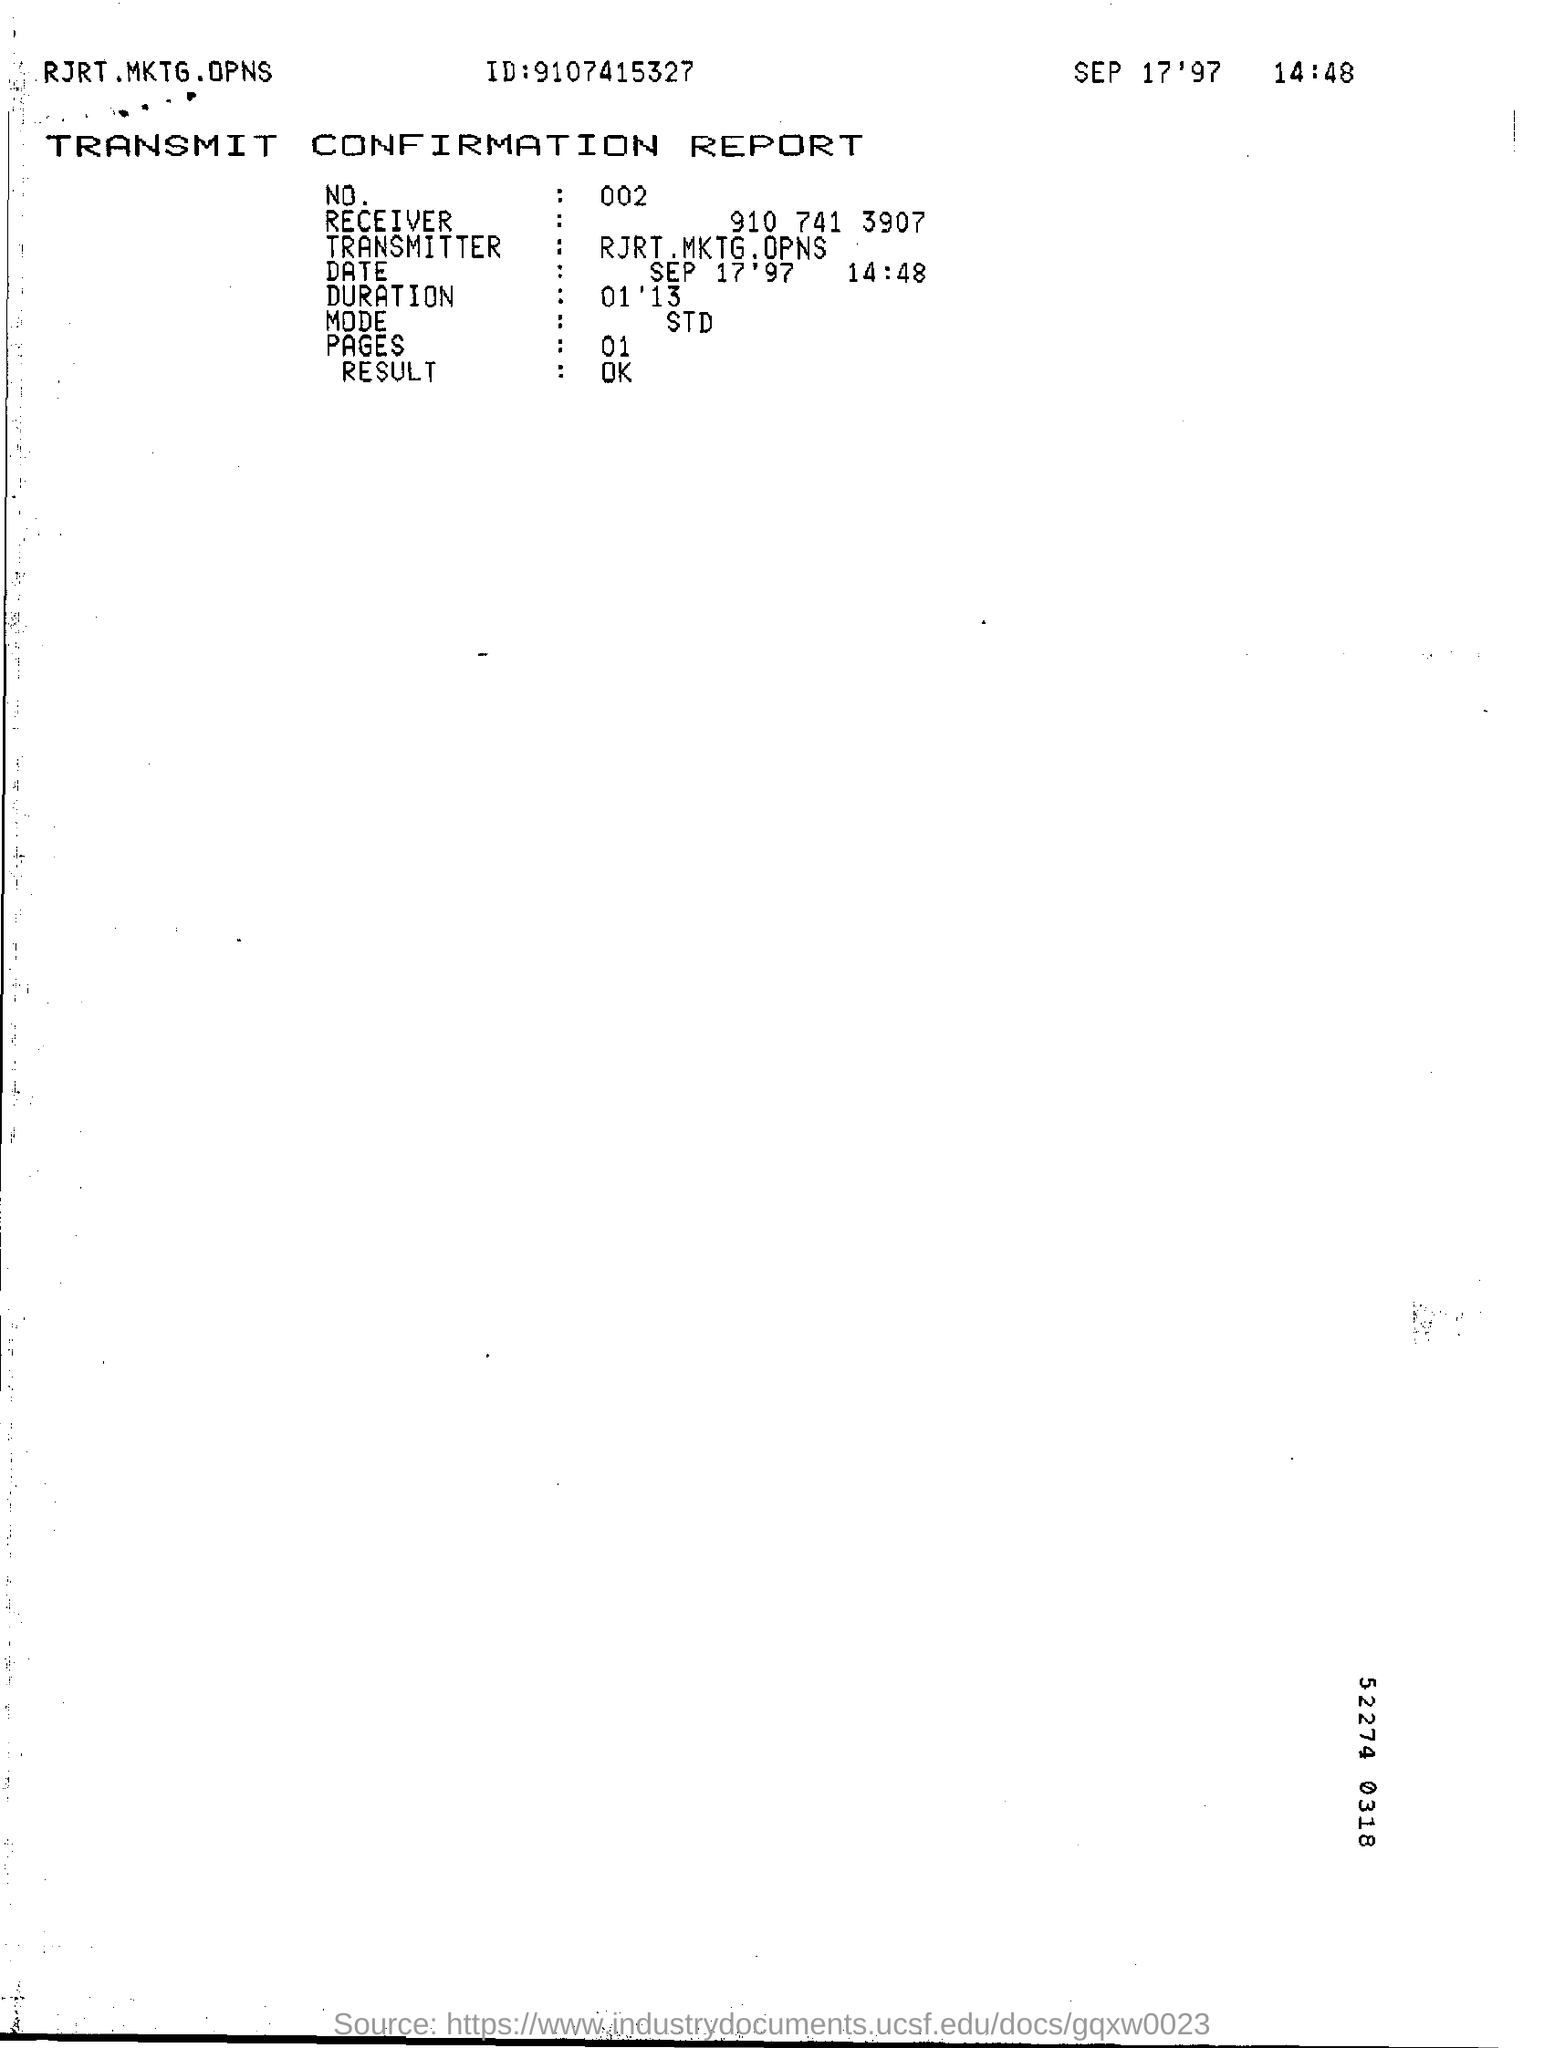What is the ID mentioned in the report?
Offer a very short reply. 9107415327. What is the Date & time mentioned in the report?
Make the answer very short. SEP 17'97                         14:48. 